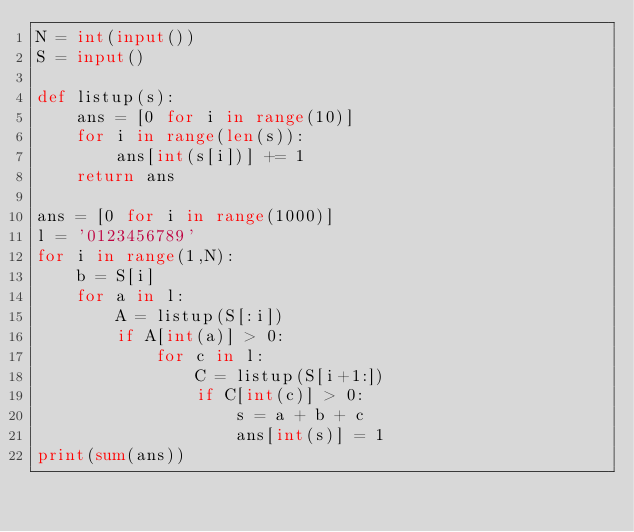Convert code to text. <code><loc_0><loc_0><loc_500><loc_500><_Python_>N = int(input())
S = input()

def listup(s):
    ans = [0 for i in range(10)]
    for i in range(len(s)):
        ans[int(s[i])] += 1
    return ans

ans = [0 for i in range(1000)]
l = '0123456789'
for i in range(1,N):
    b = S[i]
    for a in l:
        A = listup(S[:i])
        if A[int(a)] > 0:
            for c in l:
                C = listup(S[i+1:])
                if C[int(c)] > 0:
                    s = a + b + c
                    ans[int(s)] = 1
print(sum(ans))</code> 